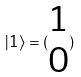<formula> <loc_0><loc_0><loc_500><loc_500>| 1 \rangle = ( \begin{matrix} 1 \\ 0 \end{matrix} )</formula> 